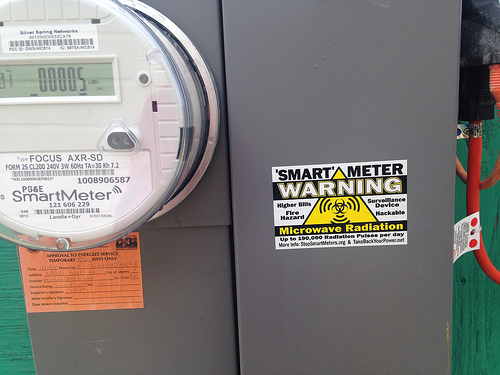<image>
Is the red wire in front of the orange label? No. The red wire is not in front of the orange label. The spatial positioning shows a different relationship between these objects. 